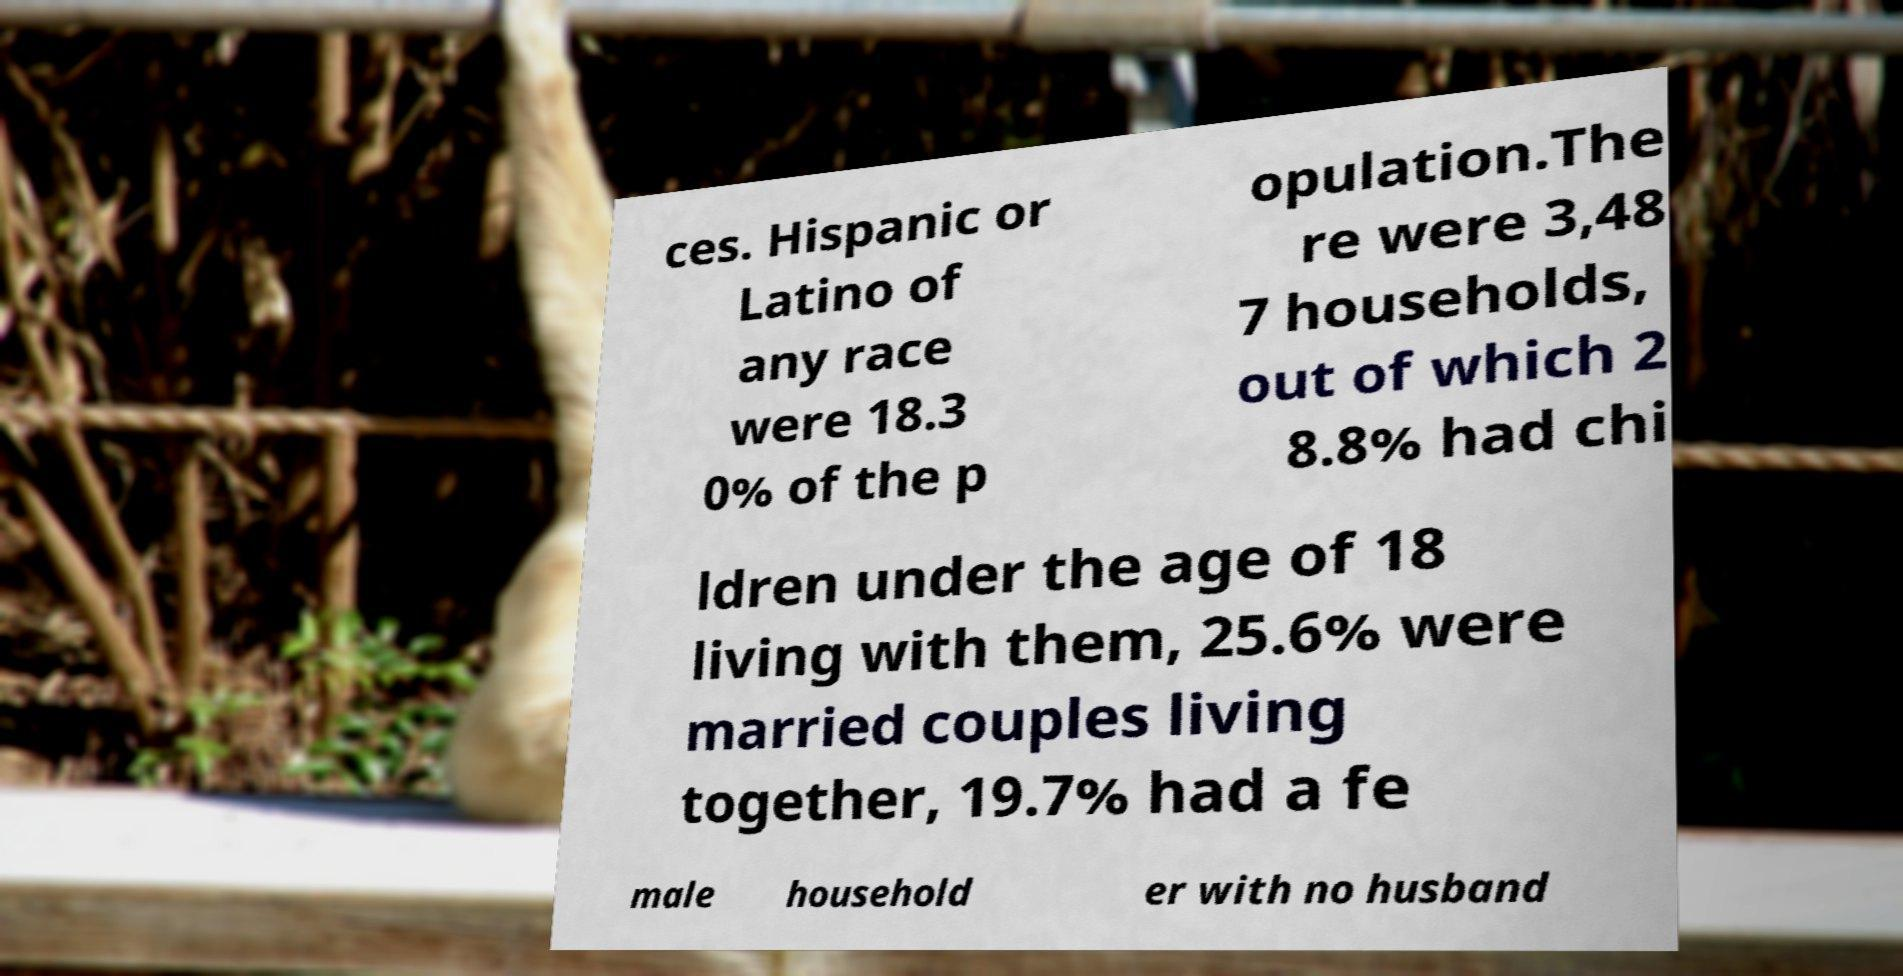Could you extract and type out the text from this image? ces. Hispanic or Latino of any race were 18.3 0% of the p opulation.The re were 3,48 7 households, out of which 2 8.8% had chi ldren under the age of 18 living with them, 25.6% were married couples living together, 19.7% had a fe male household er with no husband 